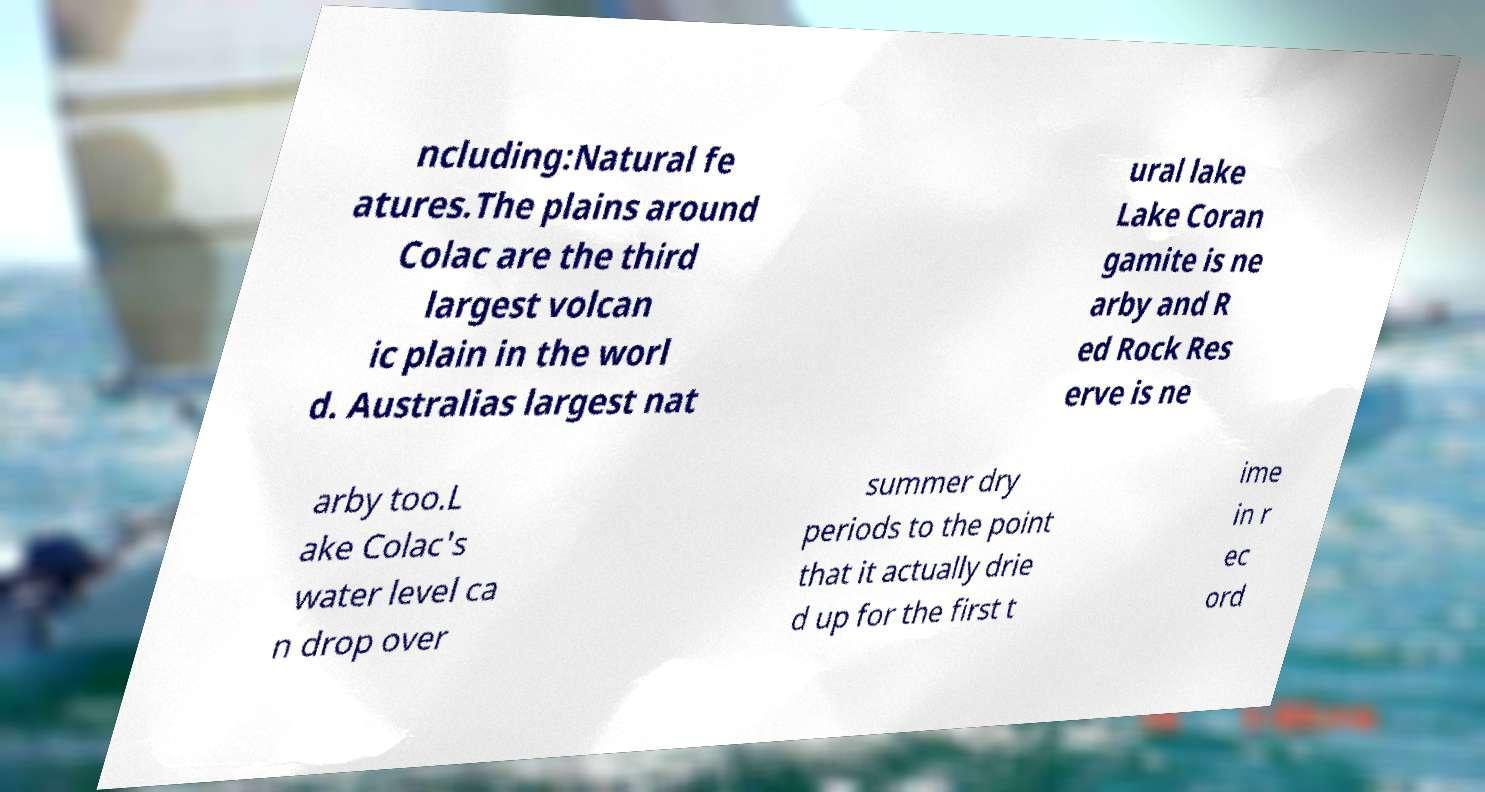Please identify and transcribe the text found in this image. ncluding:Natural fe atures.The plains around Colac are the third largest volcan ic plain in the worl d. Australias largest nat ural lake Lake Coran gamite is ne arby and R ed Rock Res erve is ne arby too.L ake Colac's water level ca n drop over summer dry periods to the point that it actually drie d up for the first t ime in r ec ord 